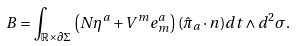Convert formula to latex. <formula><loc_0><loc_0><loc_500><loc_500>B = \int _ { \mathbb { R } \times \partial \Sigma } \left ( N \eta ^ { a } + V ^ { m } e ^ { a } _ { m } \right ) ( \hat { \pi } _ { a } \cdot n ) d t \wedge d ^ { 2 } \sigma .</formula> 